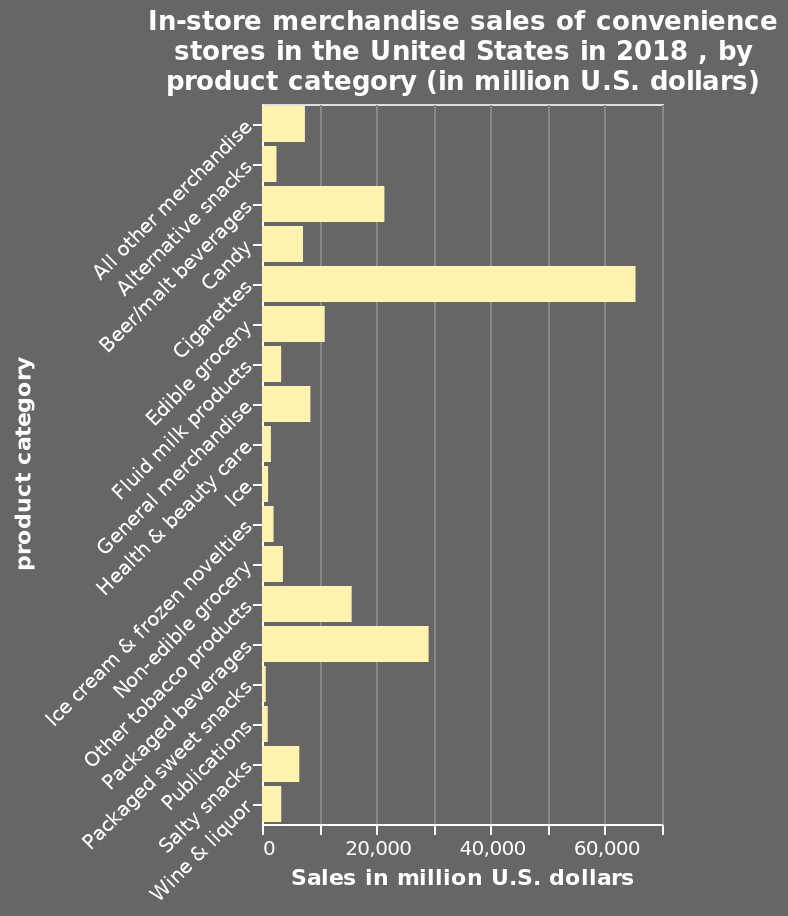<image>
What was the total sales value of cigarettes in 2018?  The total sales value of cigarettes in 2018 amounted to $60,000. What does the y-axis represent in the bar plot? The y-axis represents the different product categories. What is the topic of the bar plot? The topic of the bar plot is the in-store merchandise sales of convenience stores in the United States in 2018, categorized by product category. please describe the details of the chart In-store merchandise sales of convenience stores in the United States in 2018 , by product category (in million U.S. dollars) is a bar plot. On the y-axis, product category is shown. The x-axis measures Sales in million U.S. dollars. 